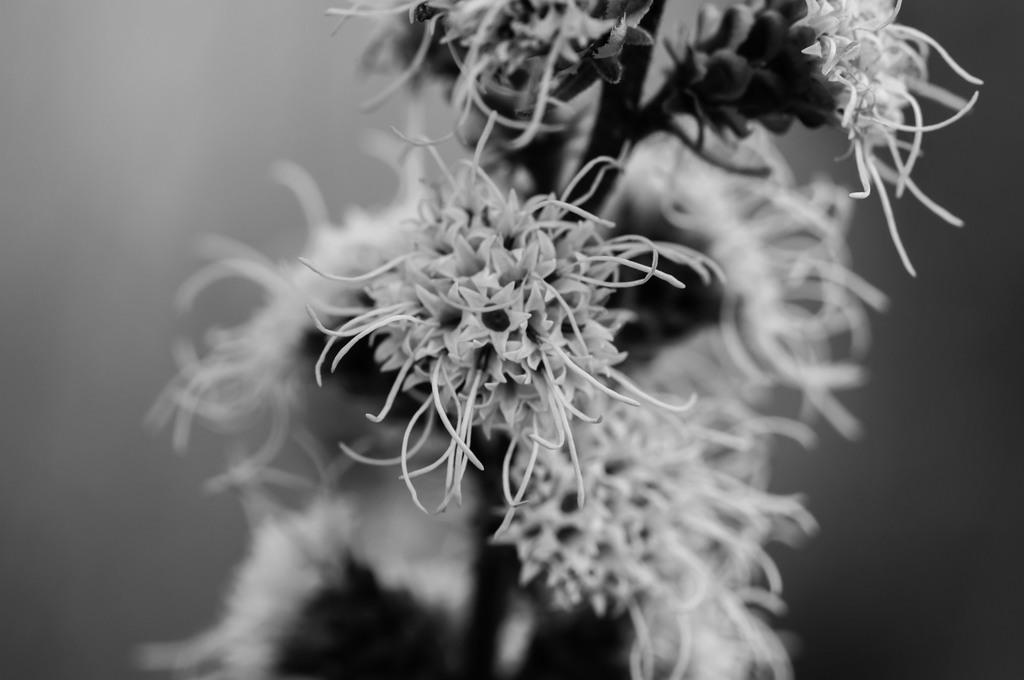Could you give a brief overview of what you see in this image? In this image we can see the spider flowers. 